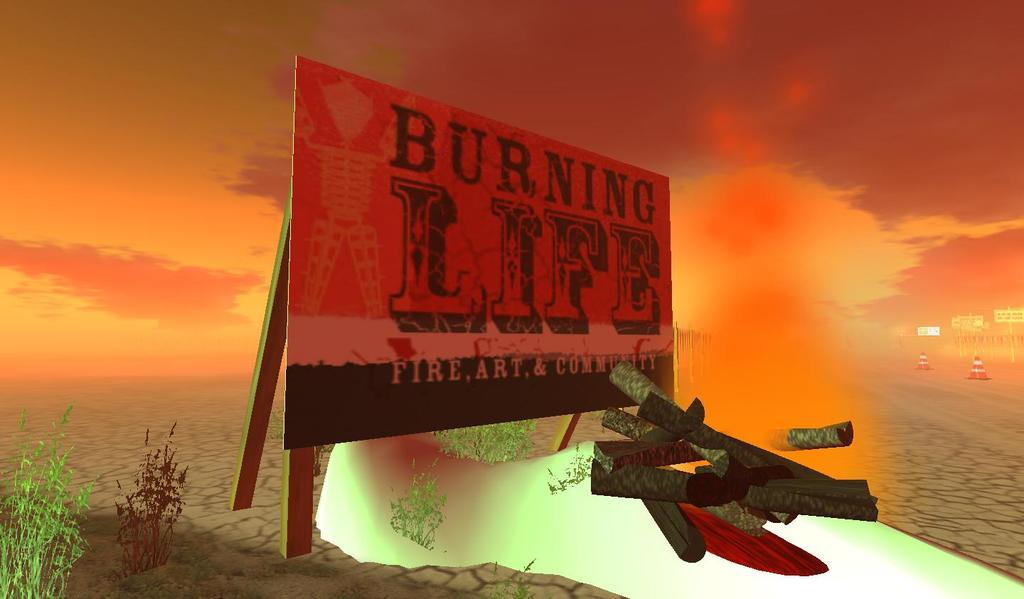<image>
Summarize the visual content of the image. A billboard for Burning Life sits in a dry desert with fire in the background 